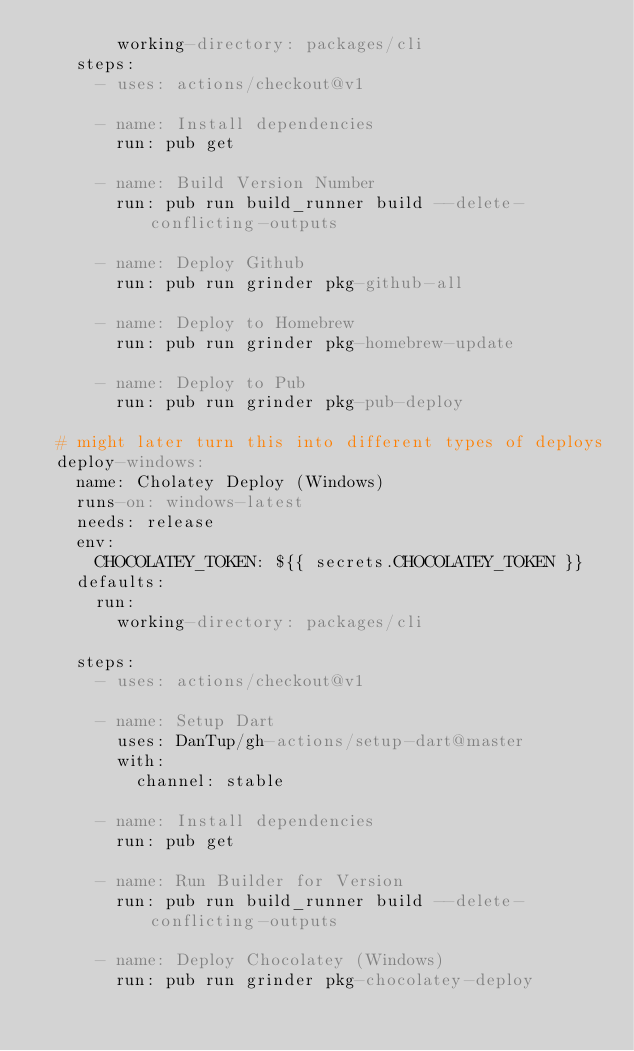Convert code to text. <code><loc_0><loc_0><loc_500><loc_500><_YAML_>        working-directory: packages/cli
    steps:
      - uses: actions/checkout@v1

      - name: Install dependencies
        run: pub get

      - name: Build Version Number
        run: pub run build_runner build --delete-conflicting-outputs

      - name: Deploy Github
        run: pub run grinder pkg-github-all

      - name: Deploy to Homebrew
        run: pub run grinder pkg-homebrew-update

      - name: Deploy to Pub
        run: pub run grinder pkg-pub-deploy

  # might later turn this into different types of deploys
  deploy-windows:
    name: Cholatey Deploy (Windows)
    runs-on: windows-latest
    needs: release
    env:
      CHOCOLATEY_TOKEN: ${{ secrets.CHOCOLATEY_TOKEN }}
    defaults:
      run:
        working-directory: packages/cli

    steps:
      - uses: actions/checkout@v1

      - name: Setup Dart
        uses: DanTup/gh-actions/setup-dart@master
        with:
          channel: stable

      - name: Install dependencies
        run: pub get

      - name: Run Builder for Version
        run: pub run build_runner build --delete-conflicting-outputs

      - name: Deploy Chocolatey (Windows)
        run: pub run grinder pkg-chocolatey-deploy
</code> 